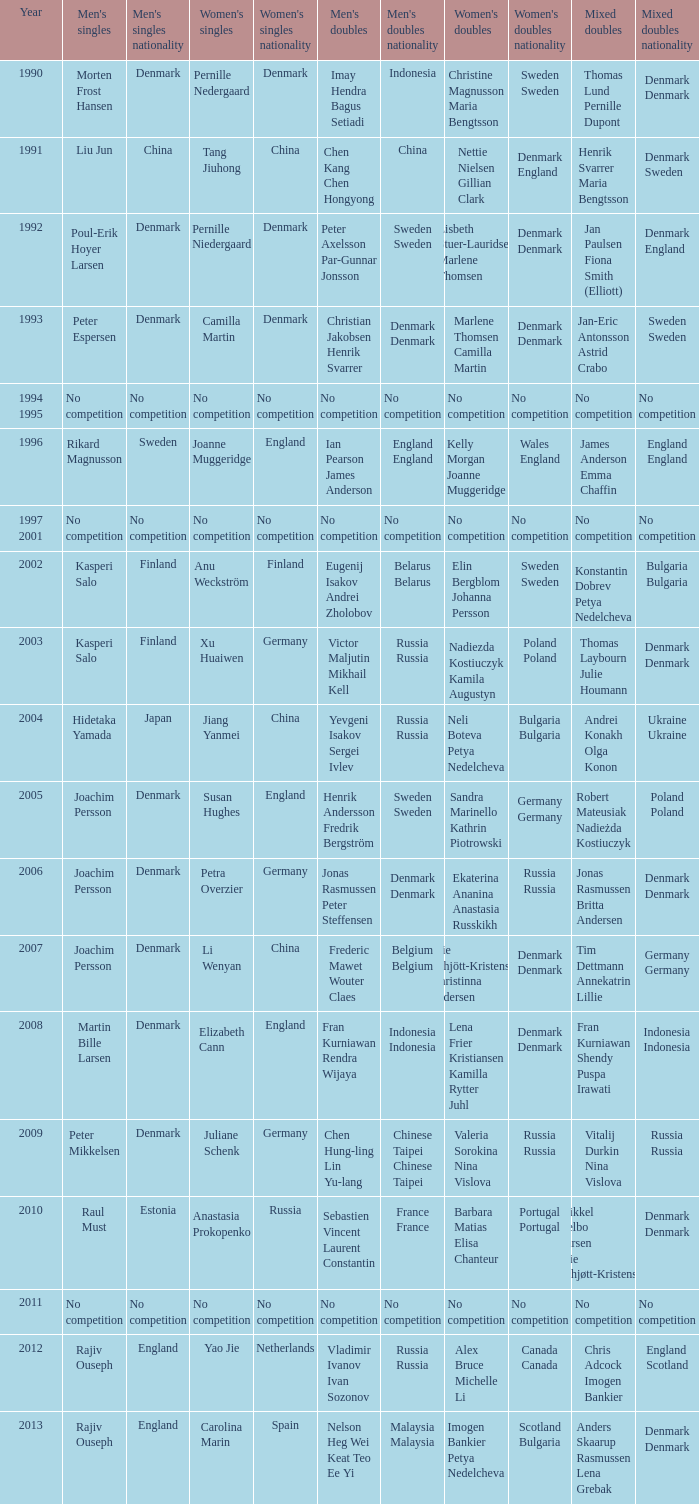Who won the Mixed doubles when Juliane Schenk won the Women's Singles? Vitalij Durkin Nina Vislova. 